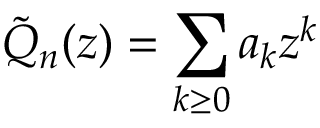<formula> <loc_0><loc_0><loc_500><loc_500>\tilde { Q } _ { n } ( z ) = \sum _ { k \geq 0 } a _ { k } z ^ { k }</formula> 